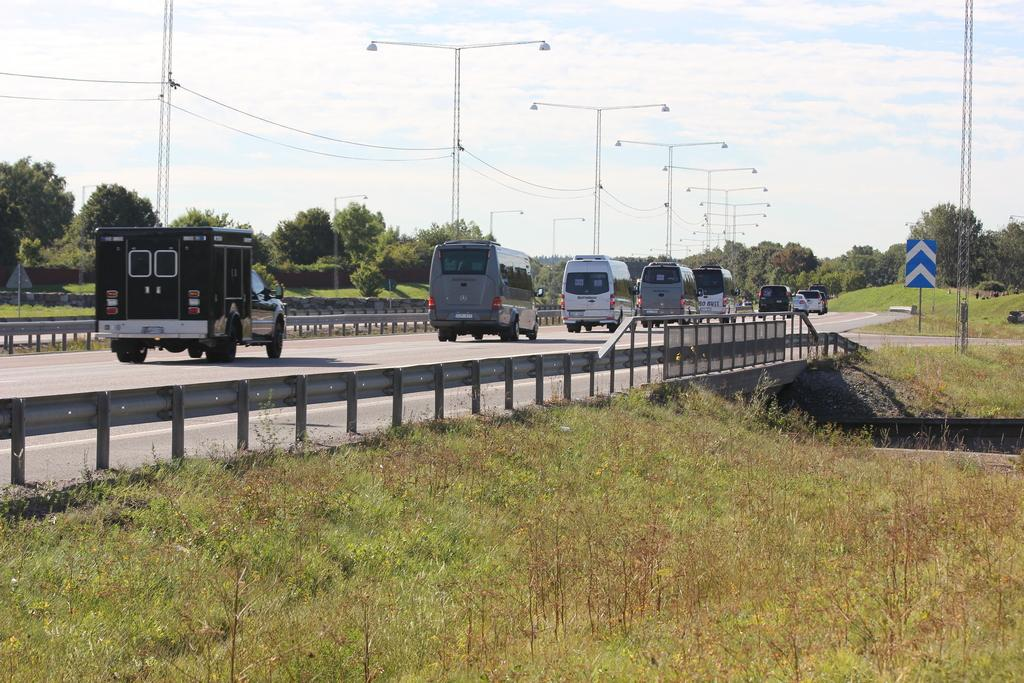What can be seen on the road in the image? There are vehicles on the road in the image. What is visible in the background of the image? There are plants and trees in the background of the image. What is the color of the plants and trees in the image? The plants and trees are green in color. What other objects can be seen in the background of the image? There are light poles in the background of the image. How would you describe the sky in the image? The sky is blue and white in color with white clouds. How many legs can be seen on the vehicles in the image? There are no visible legs on the vehicles in the image. Vehicles typically have wheels, which are not considered legs. 